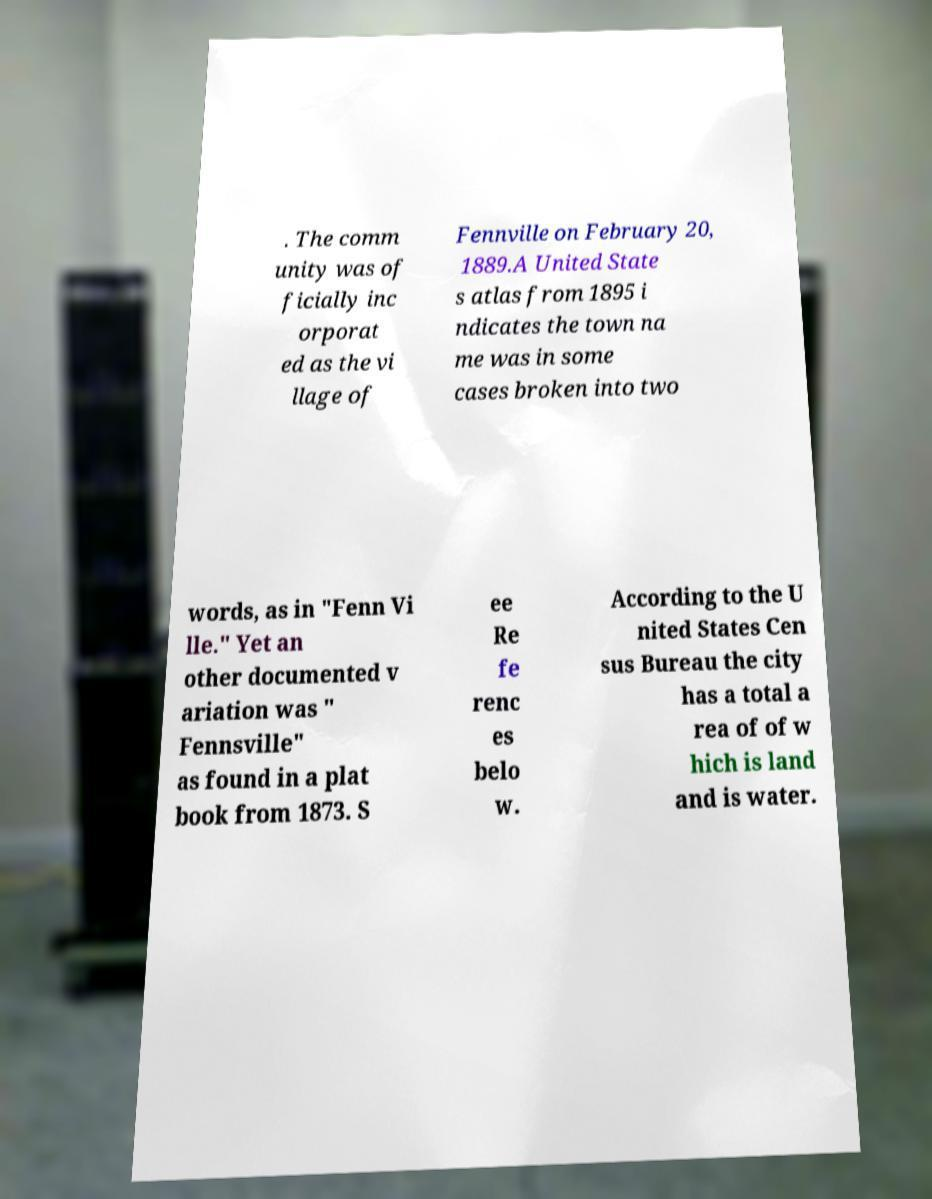Please identify and transcribe the text found in this image. . The comm unity was of ficially inc orporat ed as the vi llage of Fennville on February 20, 1889.A United State s atlas from 1895 i ndicates the town na me was in some cases broken into two words, as in "Fenn Vi lle." Yet an other documented v ariation was " Fennsville" as found in a plat book from 1873. S ee Re fe renc es belo w. According to the U nited States Cen sus Bureau the city has a total a rea of of w hich is land and is water. 